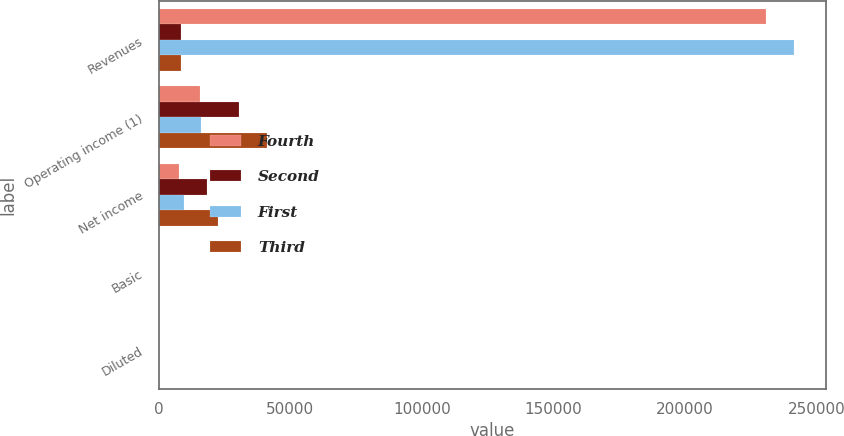Convert chart. <chart><loc_0><loc_0><loc_500><loc_500><stacked_bar_chart><ecel><fcel>Revenues<fcel>Operating income (1)<fcel>Net income<fcel>Basic<fcel>Diluted<nl><fcel>Fourth<fcel>230929<fcel>15620<fcel>7770<fcel>0.07<fcel>0.07<nl><fcel>Second<fcel>8689<fcel>30595<fcel>18244<fcel>0.16<fcel>0.16<nl><fcel>First<fcel>241360<fcel>15963<fcel>9608<fcel>0.08<fcel>0.08<nl><fcel>Third<fcel>8689<fcel>41072<fcel>22570<fcel>0.2<fcel>0.2<nl></chart> 